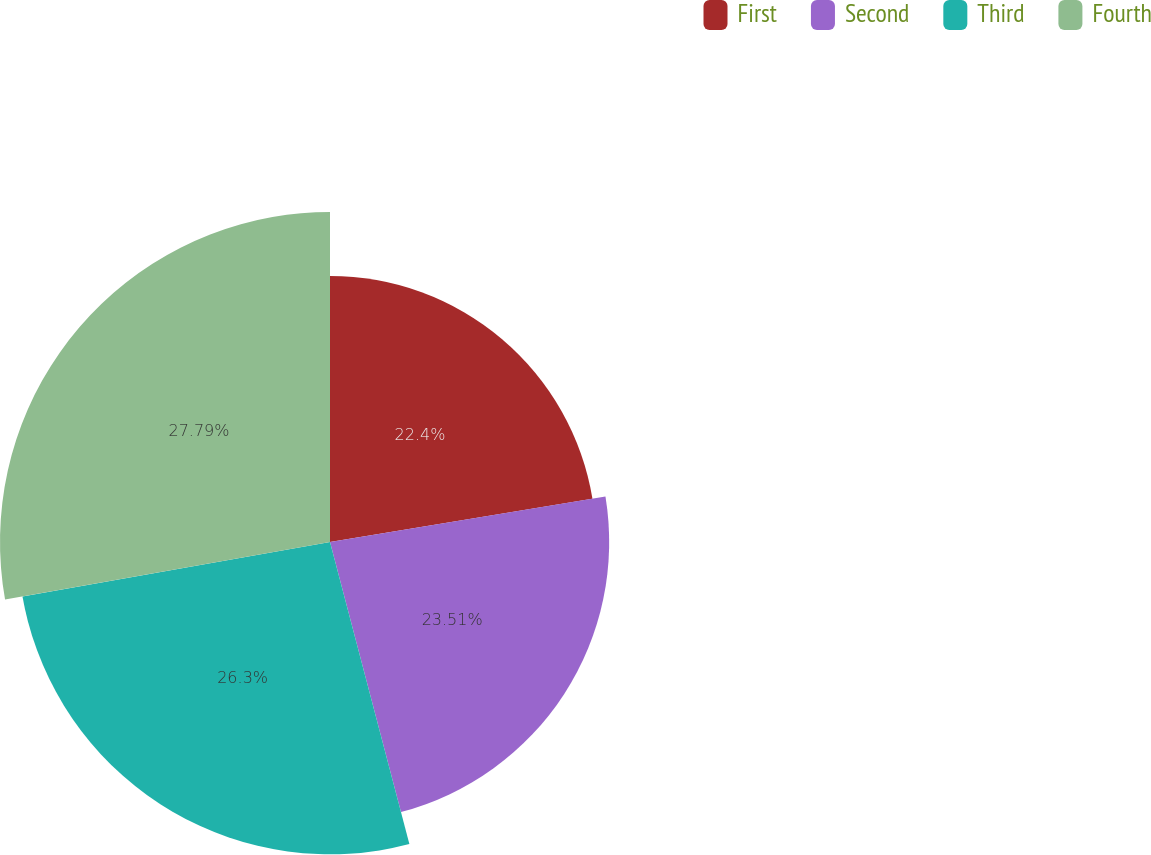<chart> <loc_0><loc_0><loc_500><loc_500><pie_chart><fcel>First<fcel>Second<fcel>Third<fcel>Fourth<nl><fcel>22.4%<fcel>23.51%<fcel>26.3%<fcel>27.79%<nl></chart> 